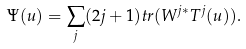Convert formula to latex. <formula><loc_0><loc_0><loc_500><loc_500>\Psi ( u ) = \sum _ { j } ( 2 j + 1 ) t r ( W ^ { j * } T ^ { j } ( u ) ) .</formula> 